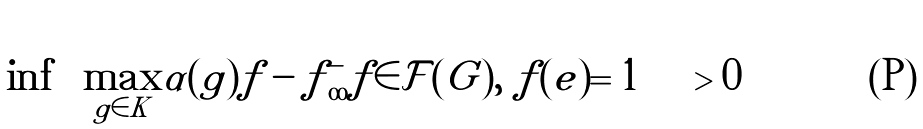Convert formula to latex. <formula><loc_0><loc_0><loc_500><loc_500>\inf \left \{ \max _ { g \in K } | \alpha ( g ) f - f | _ { \infty } ^ { - } | f \in { \mathcal { F } } ( G ) , \ f ( e ) = 1 \right \} > 0</formula> 